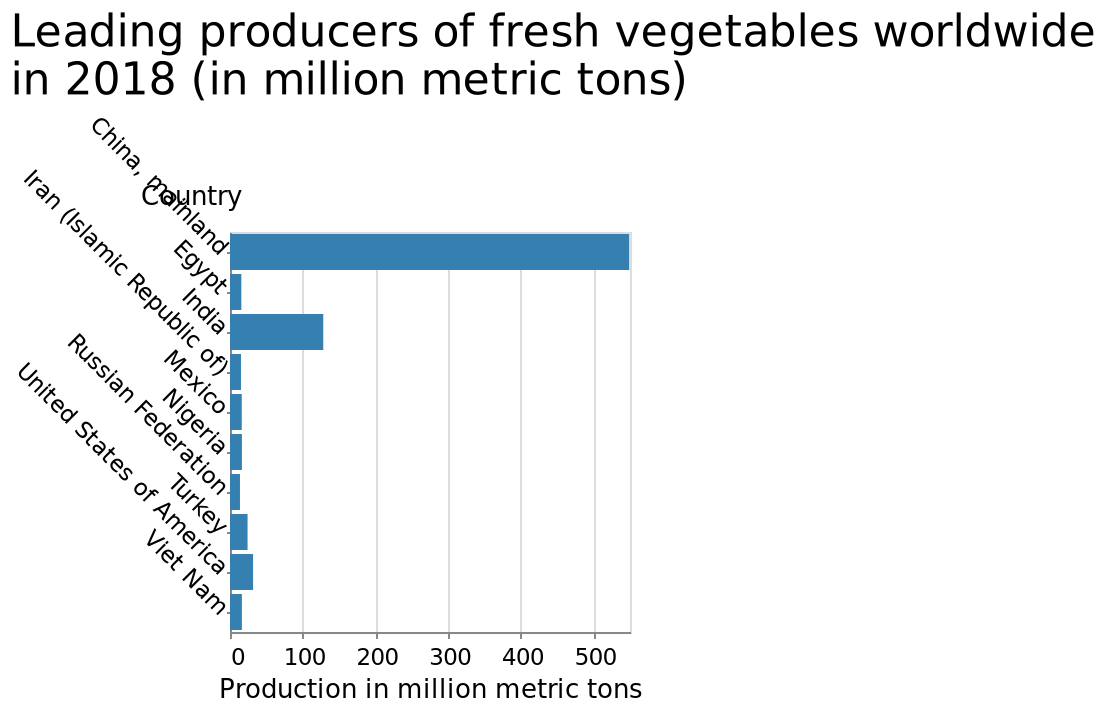<image>
please summary the statistics and relations of the chart Russian Federation has the lowest production.  China produces the most veg. Which country has the highest production? China has the highest production in terms of vegetable production. What is the country plotted at the highest position on the y-axis? Viet Nam. 